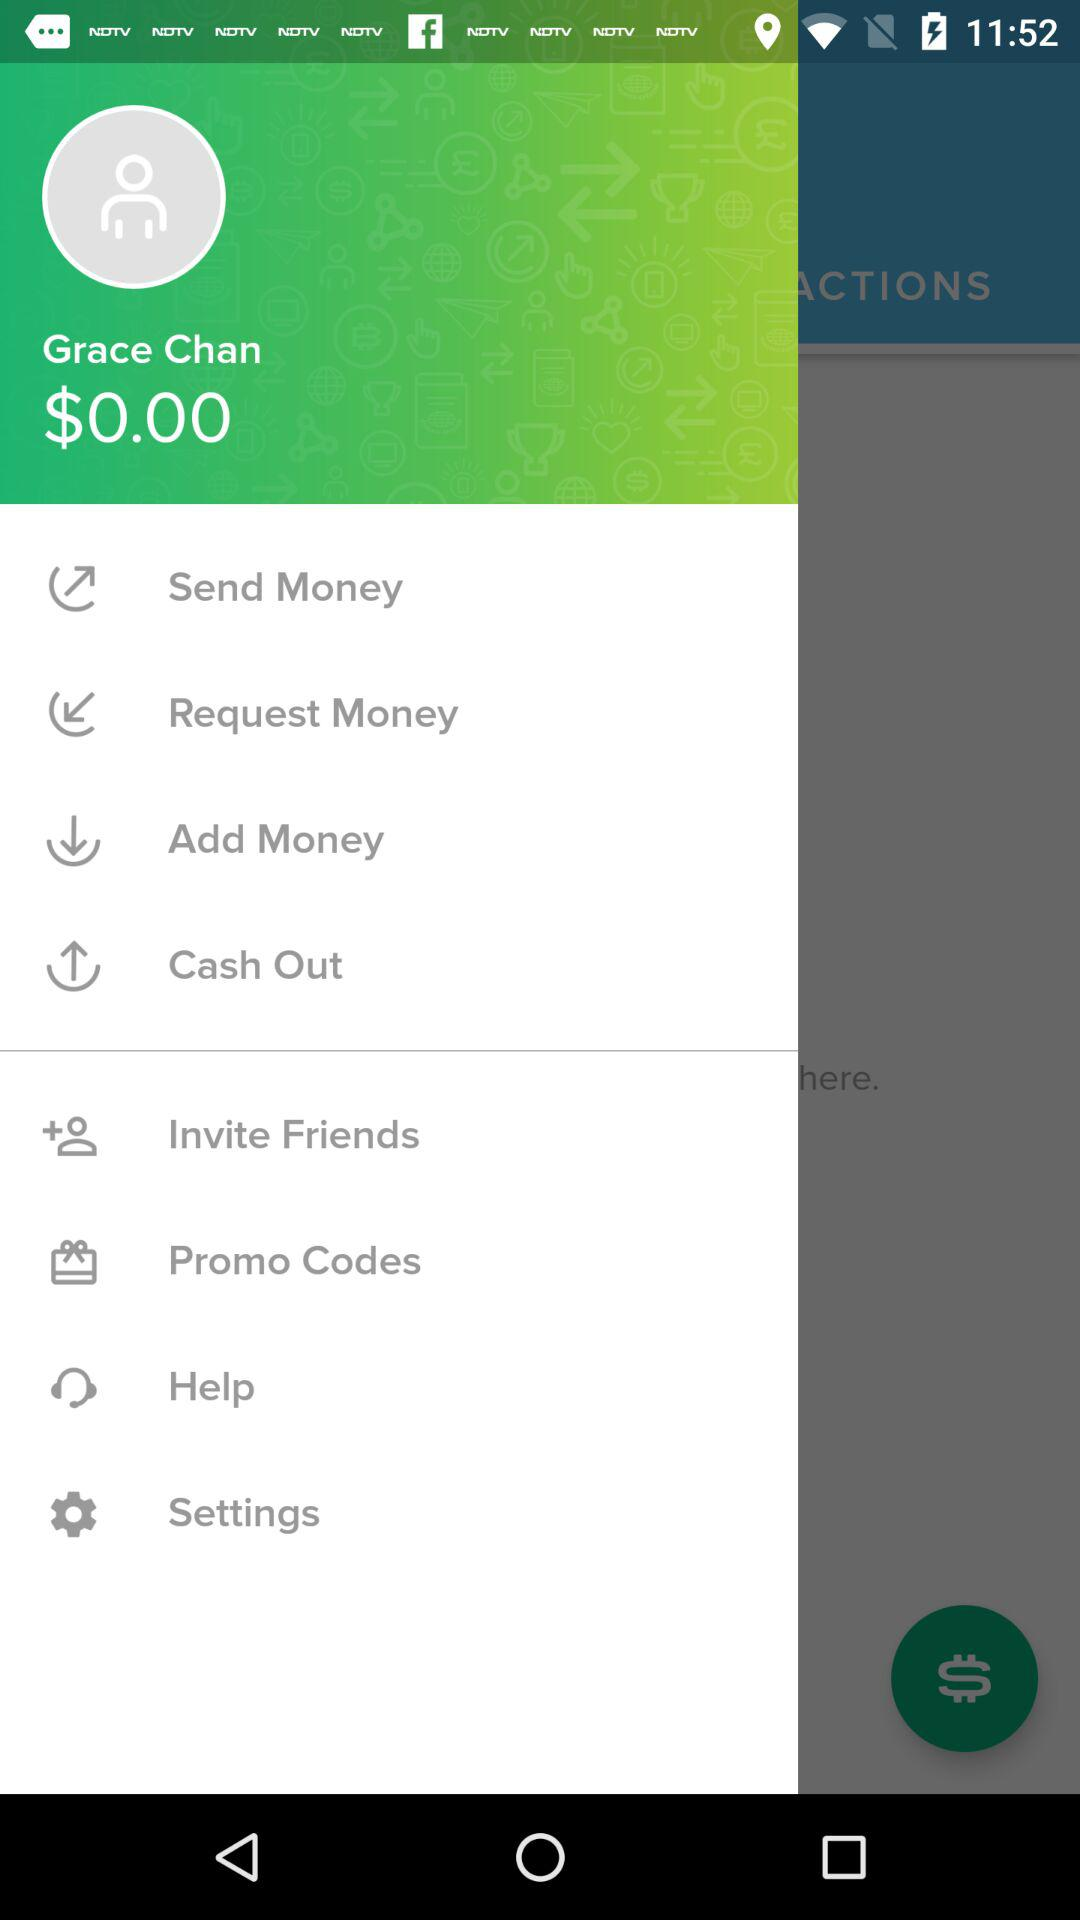What currency is shown here? The currency is $. 